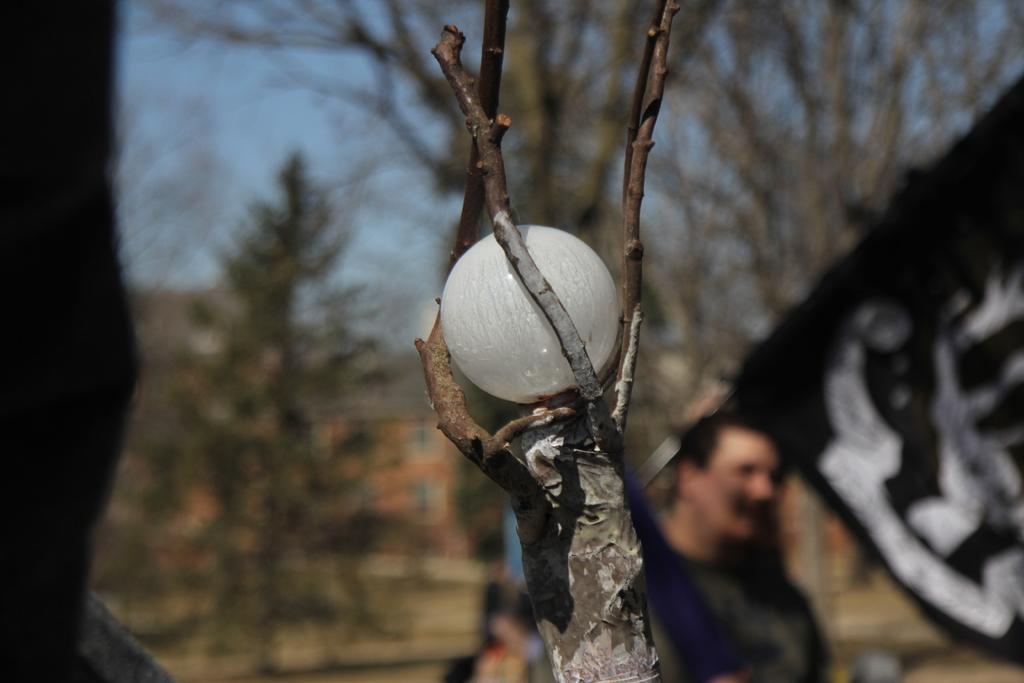In one or two sentences, can you explain what this image depicts? In this image we can see a ball on the branch of a tree. On the backside we can see the flag, a man, a group of trees, a building with windows and the sky which looks cloudy. 